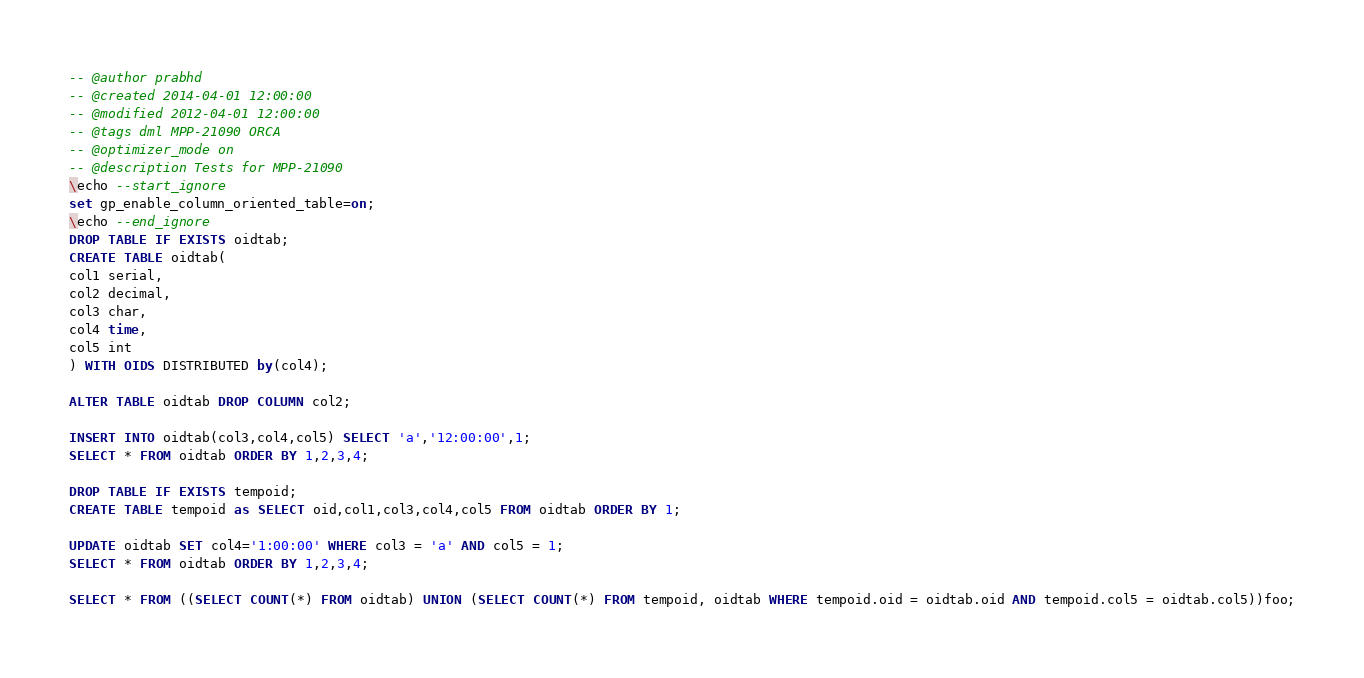<code> <loc_0><loc_0><loc_500><loc_500><_SQL_>-- @author prabhd 
-- @created 2014-04-01 12:00:00
-- @modified 2012-04-01 12:00:00
-- @tags dml MPP-21090 ORCA
-- @optimizer_mode on	
-- @description Tests for MPP-21090
\echo --start_ignore
set gp_enable_column_oriented_table=on;
\echo --end_ignore
DROP TABLE IF EXISTS oidtab;
CREATE TABLE oidtab(
col1 serial,
col2 decimal,
col3 char,
col4 time,
col5 int
) WITH OIDS DISTRIBUTED by(col4);

ALTER TABLE oidtab DROP COLUMN col2;

INSERT INTO oidtab(col3,col4,col5) SELECT 'a','12:00:00',1;
SELECT * FROM oidtab ORDER BY 1,2,3,4;

DROP TABLE IF EXISTS tempoid;
CREATE TABLE tempoid as SELECT oid,col1,col3,col4,col5 FROM oidtab ORDER BY 1;

UPDATE oidtab SET col4='1:00:00' WHERE col3 = 'a' AND col5 = 1;
SELECT * FROM oidtab ORDER BY 1,2,3,4;

SELECT * FROM ((SELECT COUNT(*) FROM oidtab) UNION (SELECT COUNT(*) FROM tempoid, oidtab WHERE tempoid.oid = oidtab.oid AND tempoid.col5 = oidtab.col5))foo;










</code> 